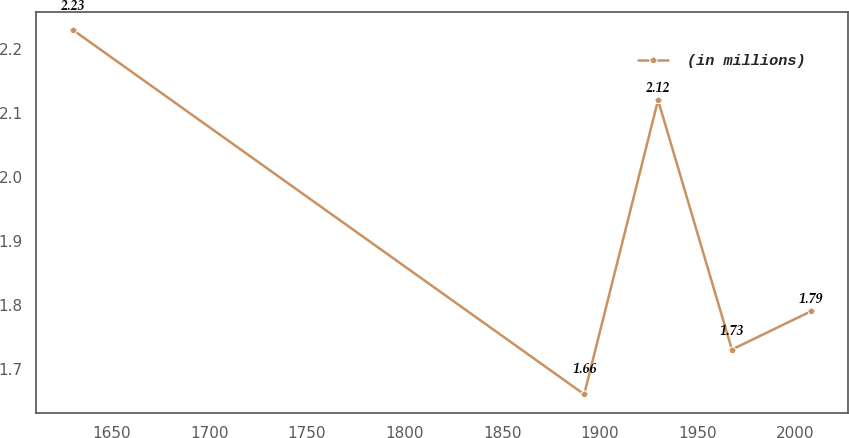Convert chart. <chart><loc_0><loc_0><loc_500><loc_500><line_chart><ecel><fcel>(in millions)<nl><fcel>1629.91<fcel>2.23<nl><fcel>1892.02<fcel>1.66<nl><fcel>1929.86<fcel>2.12<nl><fcel>1967.7<fcel>1.73<nl><fcel>2008.33<fcel>1.79<nl></chart> 